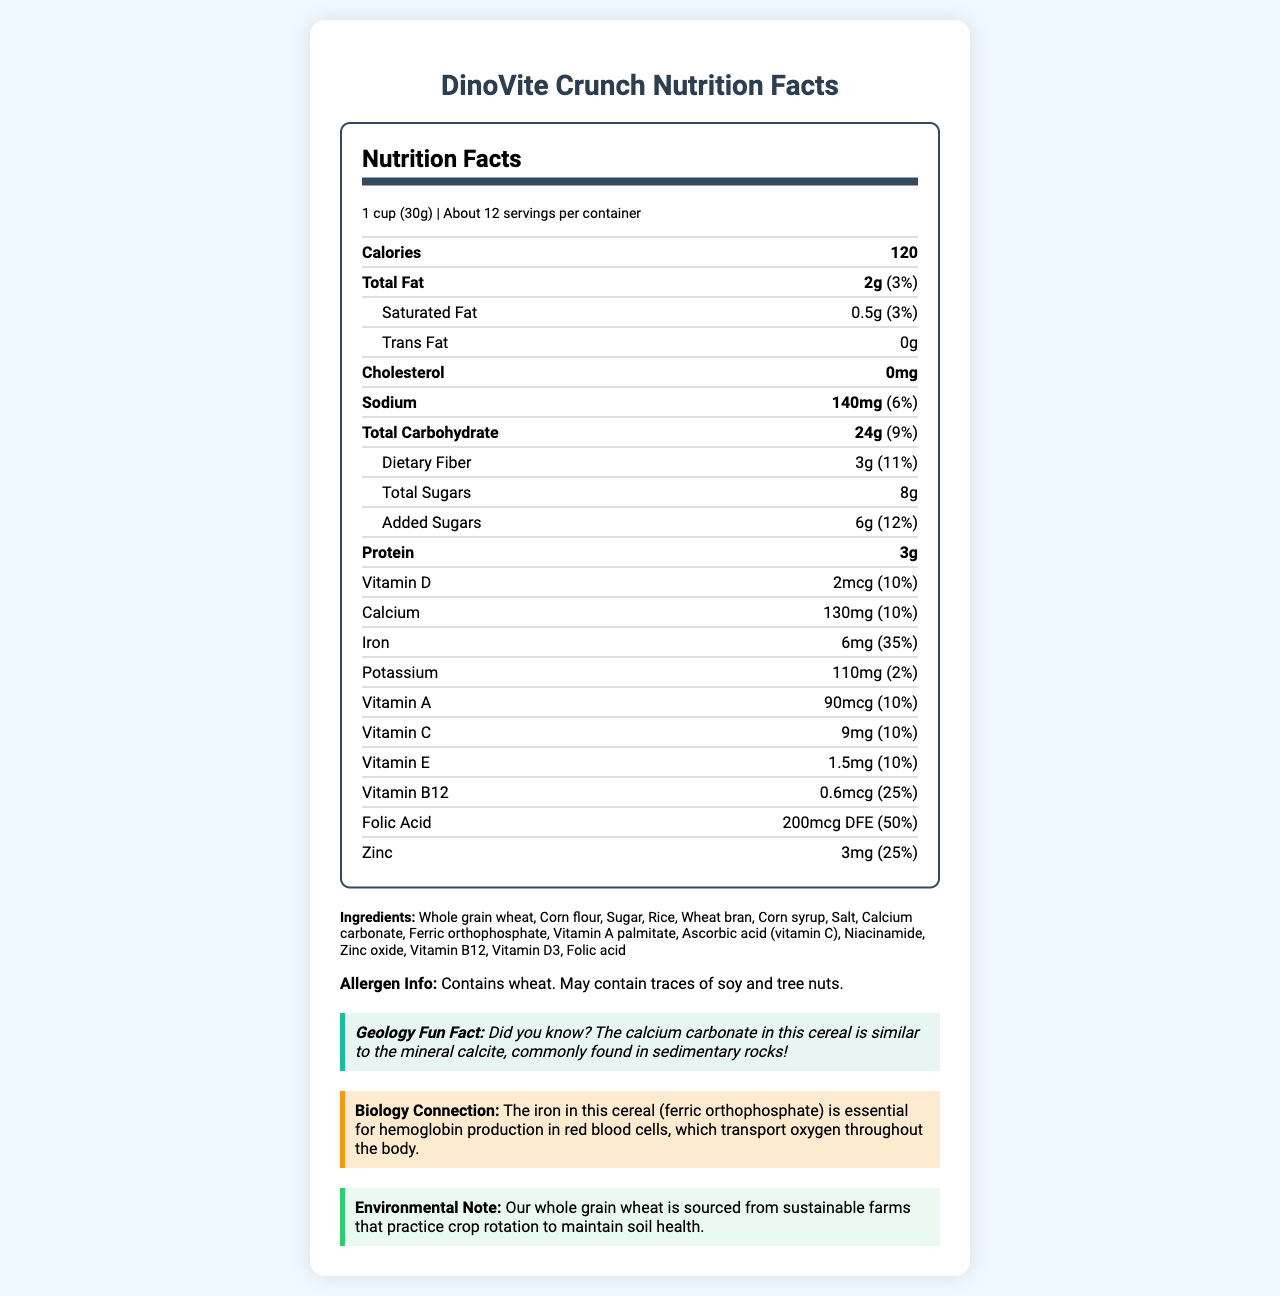What is the serving size for DinoVite Crunch? The document states that the serving size for DinoVite Crunch is 1 cup (30g).
Answer: 1 cup (30g) How many servings per container are there in DinoVite Crunch? The document indicates that there are about 12 servings per container.
Answer: About 12 What is the total fiber content per serving? The document states that each serving contains 3g of dietary fiber.
Answer: 3g What is the percentage daily value of iron per serving? The document lists the daily value of iron per serving as 35%.
Answer: 35% What allergen information is provided for DinoVite Crunch? The allergen information noted in the document states that DinoVite Crunch contains wheat and may contain traces of soy and tree nuts.
Answer: Contains wheat. May contain traces of soy and tree nuts. How much added sugars are there in one serving of DinoVite Crunch? A. 6g B. 8g C. 10g D. 12g The document specifies that there are 6g of added sugars per serving.
Answer: A. 6g Which nutrient has the highest percentage daily value? I. Vitamin B12 II. Zinc III. Iron IV. Folic Acid The document shows that folic acid has a daily value of 50%, which is the highest among the listed nutrients.
Answer: IV. Folic Acid Is DinoVite Crunch suitable for someone avoiding cholesterol? The document states that DinoVite Crunch contains 0mg of cholesterol, making it suitable for someone avoiding cholesterol.
Answer: Yes Describe the main idea of the document. The document gives comprehensive details about DinoVite Crunch, focusing on its nutritional aspects, ingredients, allergen warnings, and various interesting and useful facts related to geology, biology, and the environment.
Answer: The document provides detailed nutritional information for DinoVite Crunch, a vitamin-fortified breakfast cereal. It includes serving size, calories, and nutrient content, along with a list of ingredients, allergen information, and environmental notes. The cereal is targeted towards children and adolescents aged 6-16. How many grams of protein does one serving of DinoVite Crunch contain? The document lists that one serving contains 3g of protein.
Answer: 3g What is the main ingredient in DinoVite Crunch? The first ingredient listed is whole grain wheat, indicating it is the main ingredient.
Answer: Whole grain wheat What is the main purpose of ferric orthophosphate in the cereal? The document states that ferric orthophosphate (iron) is essential for hemoglobin production in red blood cells, which transport oxygen throughout the body.
Answer: Essential for hemoglobin production in red blood cells Can you determine the price of DinoVite Crunch from the document? The document provides detailed nutritional information, ingredients, and other content but does not mention the price.
Answer: Cannot be determined What is a geology fun fact mentioned in the document? The document includes a fun fact stating that the calcium carbonate in this cereal is similar to the mineral calcite, commonly found in sedimentary rocks.
Answer: The calcium carbonate in this cereal is similar to the mineral calcite, commonly found in sedimentary rocks! 